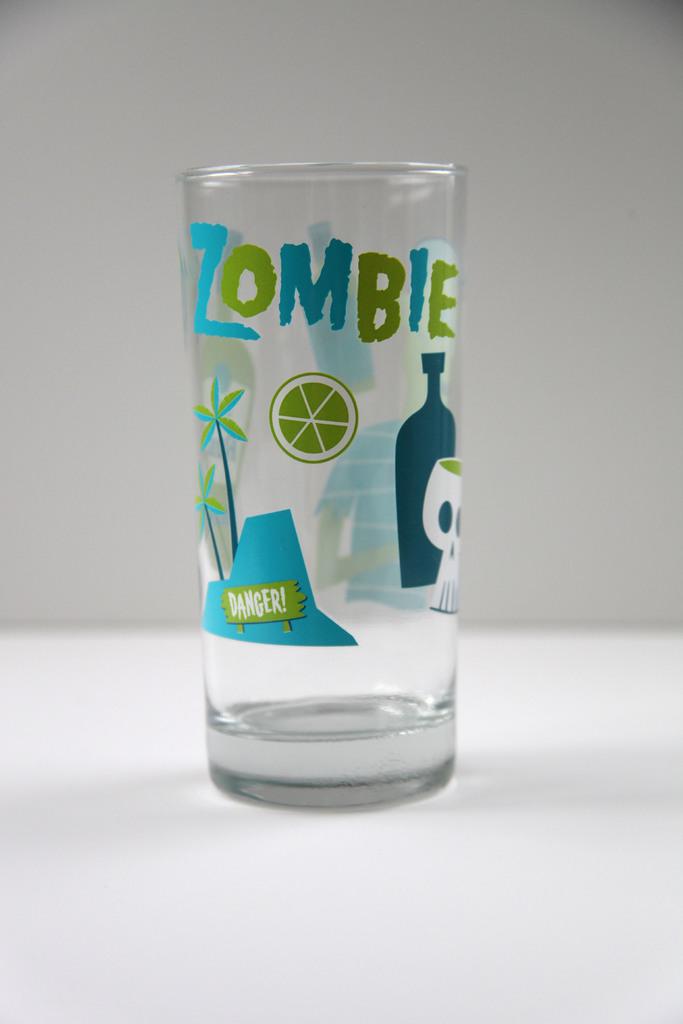What kind of glass is that?
Your answer should be very brief. Zombie. 